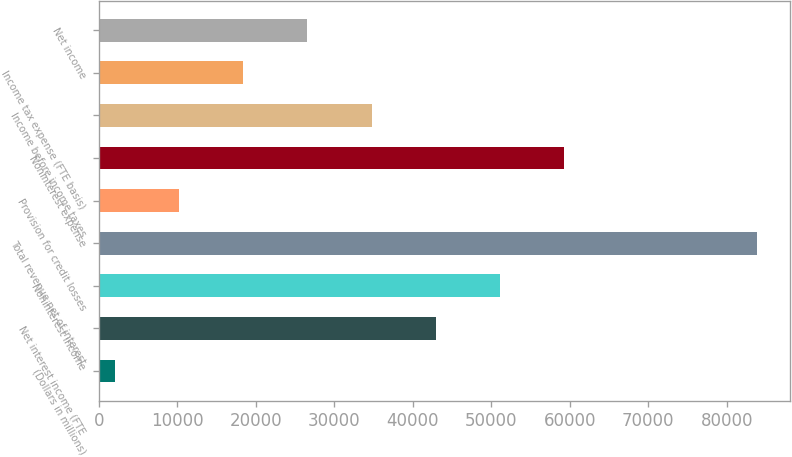<chart> <loc_0><loc_0><loc_500><loc_500><bar_chart><fcel>(Dollars in millions)<fcel>Net interest income (FTE<fcel>Noninterest income<fcel>Total revenue net of interest<fcel>Provision for credit losses<fcel>Noninterest expense<fcel>Income before income taxes<fcel>Income tax expense (FTE basis)<fcel>Net income<nl><fcel>2015<fcel>42934.5<fcel>51118.4<fcel>83854<fcel>10198.9<fcel>59302.3<fcel>34750.6<fcel>18382.8<fcel>26566.7<nl></chart> 